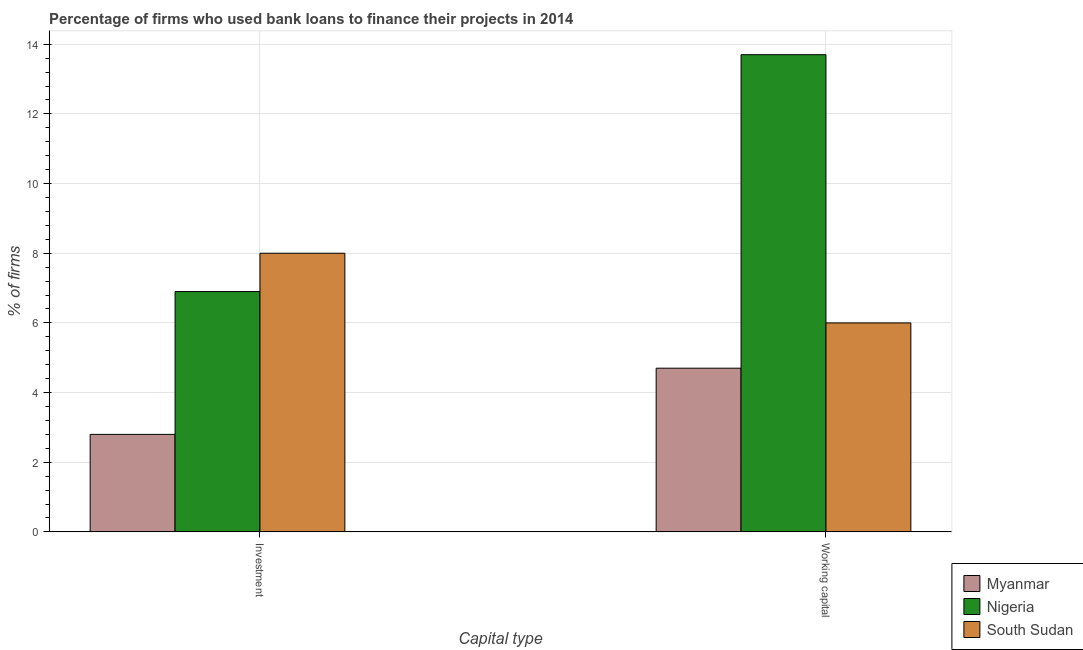How many groups of bars are there?
Your response must be concise. 2. Are the number of bars per tick equal to the number of legend labels?
Keep it short and to the point. Yes. Are the number of bars on each tick of the X-axis equal?
Provide a short and direct response. Yes. How many bars are there on the 2nd tick from the left?
Provide a succinct answer. 3. What is the label of the 2nd group of bars from the left?
Give a very brief answer. Working capital. What is the percentage of firms using banks to finance working capital in South Sudan?
Your answer should be compact. 6. Across all countries, what is the maximum percentage of firms using banks to finance working capital?
Your answer should be compact. 13.7. Across all countries, what is the minimum percentage of firms using banks to finance investment?
Offer a very short reply. 2.8. In which country was the percentage of firms using banks to finance working capital maximum?
Your answer should be very brief. Nigeria. In which country was the percentage of firms using banks to finance investment minimum?
Your answer should be very brief. Myanmar. What is the total percentage of firms using banks to finance working capital in the graph?
Your answer should be very brief. 24.4. What is the difference between the percentage of firms using banks to finance working capital in Nigeria and that in South Sudan?
Offer a very short reply. 7.7. What is the difference between the percentage of firms using banks to finance investment in Nigeria and the percentage of firms using banks to finance working capital in South Sudan?
Your answer should be compact. 0.9. What is the average percentage of firms using banks to finance working capital per country?
Give a very brief answer. 8.13. What is the ratio of the percentage of firms using banks to finance working capital in Myanmar to that in Nigeria?
Make the answer very short. 0.34. Is the percentage of firms using banks to finance working capital in Nigeria less than that in South Sudan?
Offer a very short reply. No. What does the 2nd bar from the left in Working capital represents?
Offer a terse response. Nigeria. What does the 2nd bar from the right in Working capital represents?
Offer a terse response. Nigeria. Are the values on the major ticks of Y-axis written in scientific E-notation?
Provide a short and direct response. No. Does the graph contain any zero values?
Your answer should be very brief. No. Does the graph contain grids?
Offer a very short reply. Yes. How are the legend labels stacked?
Provide a succinct answer. Vertical. What is the title of the graph?
Your answer should be compact. Percentage of firms who used bank loans to finance their projects in 2014. What is the label or title of the X-axis?
Ensure brevity in your answer.  Capital type. What is the label or title of the Y-axis?
Your response must be concise. % of firms. What is the % of firms in South Sudan in Investment?
Your response must be concise. 8. What is the % of firms of South Sudan in Working capital?
Your response must be concise. 6. Across all Capital type, what is the maximum % of firms in Myanmar?
Your answer should be compact. 4.7. Across all Capital type, what is the maximum % of firms of Nigeria?
Your response must be concise. 13.7. Across all Capital type, what is the minimum % of firms of Myanmar?
Provide a short and direct response. 2.8. Across all Capital type, what is the minimum % of firms in Nigeria?
Provide a short and direct response. 6.9. What is the total % of firms of Nigeria in the graph?
Keep it short and to the point. 20.6. What is the total % of firms of South Sudan in the graph?
Keep it short and to the point. 14. What is the difference between the % of firms in Myanmar in Investment and that in Working capital?
Make the answer very short. -1.9. What is the difference between the % of firms of South Sudan in Investment and that in Working capital?
Provide a short and direct response. 2. What is the difference between the % of firms of Myanmar in Investment and the % of firms of Nigeria in Working capital?
Give a very brief answer. -10.9. What is the difference between the % of firms of Nigeria in Investment and the % of firms of South Sudan in Working capital?
Your answer should be compact. 0.9. What is the average % of firms in Myanmar per Capital type?
Provide a short and direct response. 3.75. What is the average % of firms of South Sudan per Capital type?
Provide a short and direct response. 7. What is the difference between the % of firms of Myanmar and % of firms of South Sudan in Investment?
Keep it short and to the point. -5.2. What is the difference between the % of firms of Myanmar and % of firms of Nigeria in Working capital?
Provide a succinct answer. -9. What is the ratio of the % of firms in Myanmar in Investment to that in Working capital?
Offer a terse response. 0.6. What is the ratio of the % of firms in Nigeria in Investment to that in Working capital?
Provide a short and direct response. 0.5. What is the difference between the highest and the second highest % of firms in South Sudan?
Offer a very short reply. 2. What is the difference between the highest and the lowest % of firms in Nigeria?
Ensure brevity in your answer.  6.8. What is the difference between the highest and the lowest % of firms in South Sudan?
Provide a short and direct response. 2. 